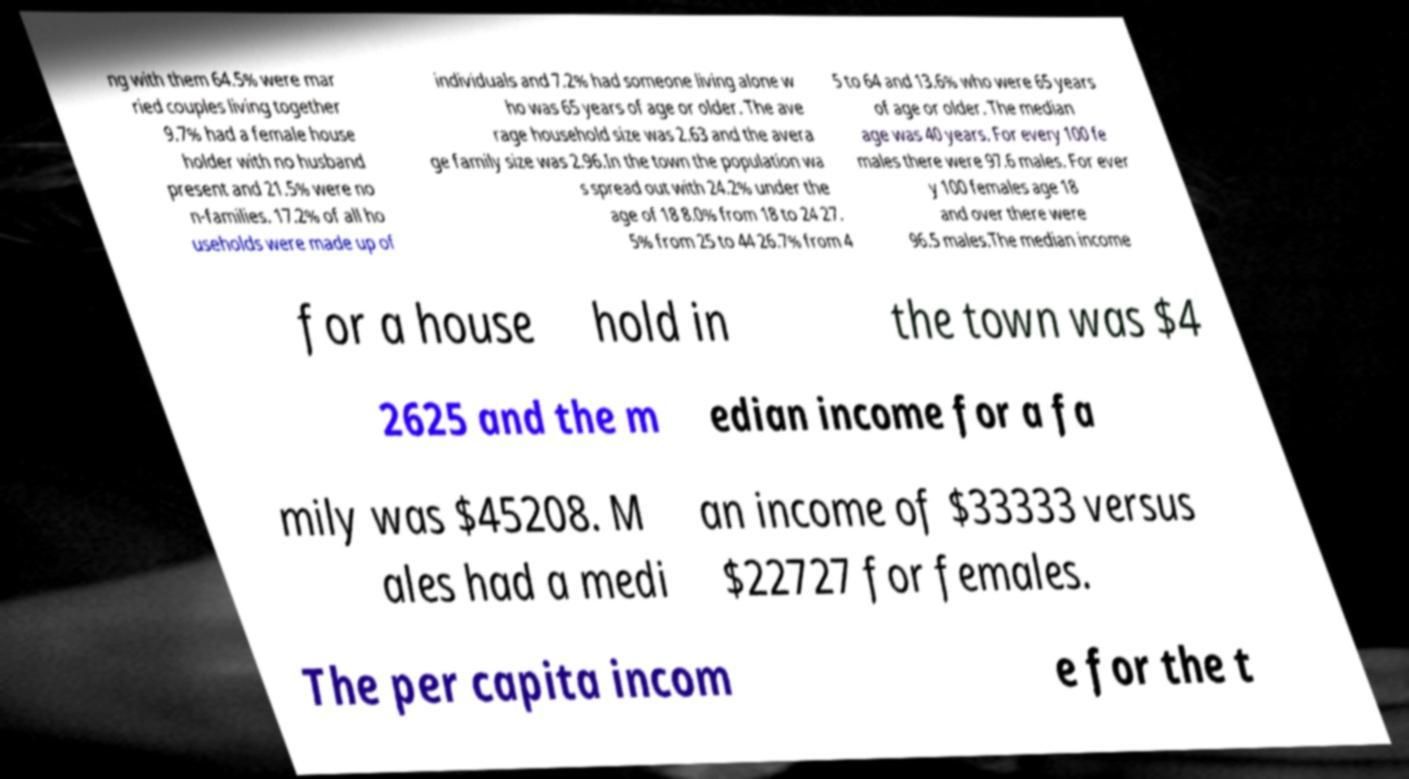Can you accurately transcribe the text from the provided image for me? ng with them 64.5% were mar ried couples living together 9.7% had a female house holder with no husband present and 21.5% were no n-families. 17.2% of all ho useholds were made up of individuals and 7.2% had someone living alone w ho was 65 years of age or older. The ave rage household size was 2.63 and the avera ge family size was 2.96.In the town the population wa s spread out with 24.2% under the age of 18 8.0% from 18 to 24 27. 5% from 25 to 44 26.7% from 4 5 to 64 and 13.6% who were 65 years of age or older. The median age was 40 years. For every 100 fe males there were 97.6 males. For ever y 100 females age 18 and over there were 96.5 males.The median income for a house hold in the town was $4 2625 and the m edian income for a fa mily was $45208. M ales had a medi an income of $33333 versus $22727 for females. The per capita incom e for the t 